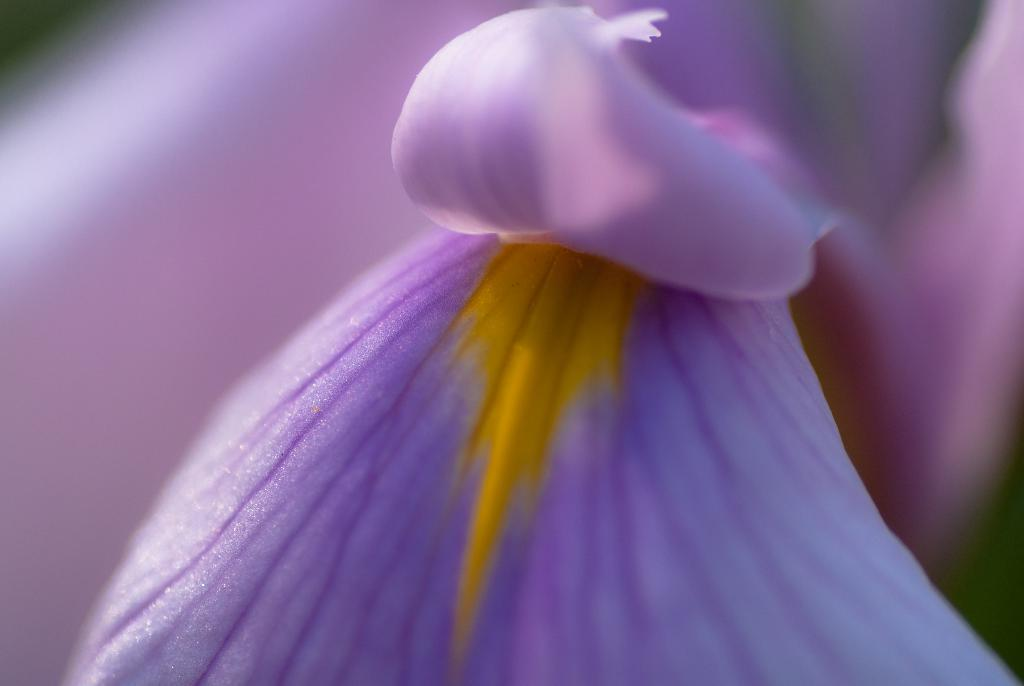What type of flower can be seen in the image? There is a purple color flower in the image. How many houses can be seen in the image? There are no houses present in the image; it features a purple color flower. What type of comfort can be provided by the flower in the image? The flower in the image is not capable of providing comfort, as it is an inanimate object. 